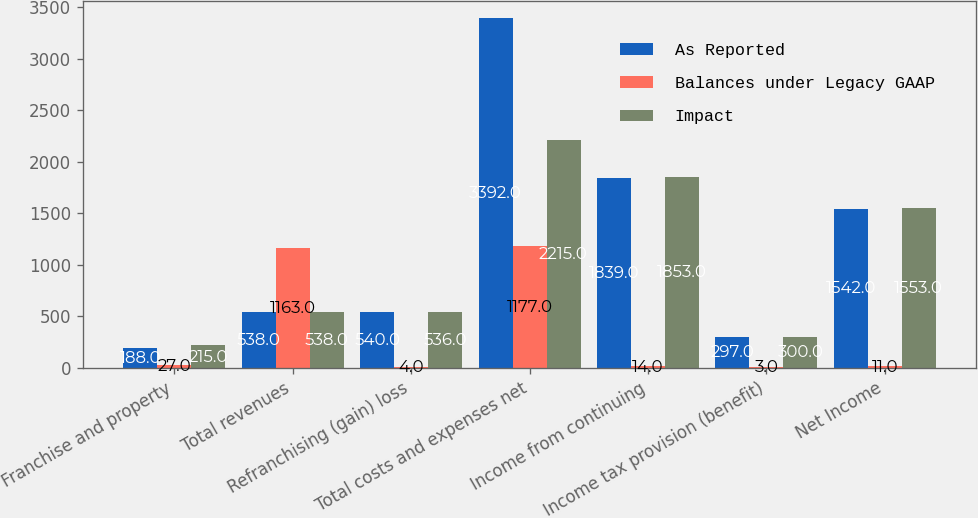<chart> <loc_0><loc_0><loc_500><loc_500><stacked_bar_chart><ecel><fcel>Franchise and property<fcel>Total revenues<fcel>Refranchising (gain) loss<fcel>Total costs and expenses net<fcel>Income from continuing<fcel>Income tax provision (benefit)<fcel>Net Income<nl><fcel>As Reported<fcel>188<fcel>538<fcel>540<fcel>3392<fcel>1839<fcel>297<fcel>1542<nl><fcel>Balances under Legacy GAAP<fcel>27<fcel>1163<fcel>4<fcel>1177<fcel>14<fcel>3<fcel>11<nl><fcel>Impact<fcel>215<fcel>538<fcel>536<fcel>2215<fcel>1853<fcel>300<fcel>1553<nl></chart> 